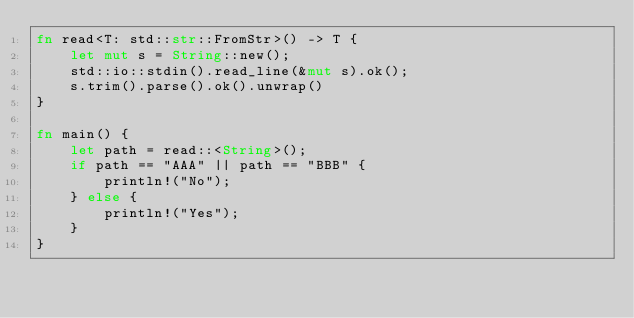<code> <loc_0><loc_0><loc_500><loc_500><_Rust_>fn read<T: std::str::FromStr>() -> T {
    let mut s = String::new();
    std::io::stdin().read_line(&mut s).ok();
    s.trim().parse().ok().unwrap()
}

fn main() {
    let path = read::<String>();
    if path == "AAA" || path == "BBB" {
        println!("No");
    } else {
        println!("Yes");
    }
}</code> 